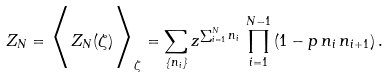<formula> <loc_0><loc_0><loc_500><loc_500>Z _ { N } = \Big < Z _ { N } ( \zeta ) \Big > _ { \zeta } = \sum _ { \{ n _ { i } \} } z ^ { \sum _ { i = 1 } ^ { N } n _ { i } } \, \prod _ { i = 1 } ^ { N - 1 } \left ( 1 - p \, n _ { i } \, n _ { i + 1 } \right ) .</formula> 